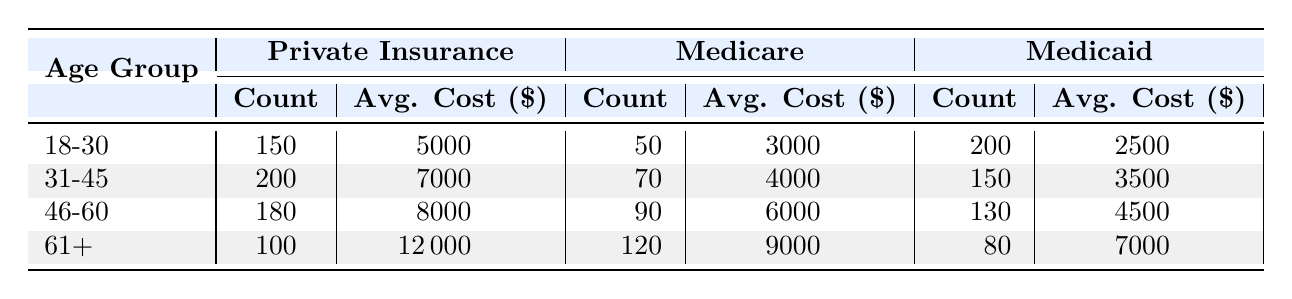What is the average cost of care for patients aged 31-45 with Medicare? From the table, the average cost of care for patients aged 31-45 under Medicare is listed as 4000.
Answer: 4000 How many patients aged 18-30 are covered by Private Insurance? The patient count for the 18-30 age group under Private Insurance is directly shown in the table as 150.
Answer: 150 Which age group has the highest average cost of care under Medicaid? Looking through the average costs for each age group under Medicaid, the age group 61+ shows an average cost of care of 7000, which is higher than the other groups (2500, 3500, and 4500 for the other age groups).
Answer: 61+ What is the total number of patients covered by Private Insurance across all age groups? Adding the patient counts for each age group under Private Insurance: 150 (18-30) + 200 (31-45) + 180 (46-60) + 100 (61+) gives a total of 630 patients.
Answer: 630 Is the average cost of care for patients aged 46-60 with Medicaid higher than that of patients aged 18-30 with Medicare? The average cost for patients aged 46-60 with Medicaid is 4500, while for those aged 18-30 with Medicare it is 3000. Since 4500 is greater than 3000, the statement is true.
Answer: Yes What is the difference in average cost of care between patients aged 61+ covered by Private Insurance and those covered by Medicare? The average cost of care for patients aged 61+ with Private Insurance is 12000, and for Medicare it is 9000. The difference is 12000 - 9000 = 3000.
Answer: 3000 How many patients are covered by Medicaid in total? The total count of patients under Medicaid is the sum of all age groups: 200 (18-30) + 150 (31-45) + 130 (46-60) + 80 (61+) which equals 560.
Answer: 560 Which insurance type has the highest average cost of care for the 46-60 age group? The average costs for the 46-60 age group are 8000 for Private Insurance, 6000 for Medicare, and 4500 for Medicaid. Here, Private Insurance has the highest average cost of 8000.
Answer: Private Insurance How many more patients are there in the age group 31-45 covered by Private Insurance compared to those covered by Medicaid? For the 31-45 age group, Private Insurance has 200 patients and Medicaid has 150. The difference is 200 - 150 = 50 more patients for Private Insurance.
Answer: 50 